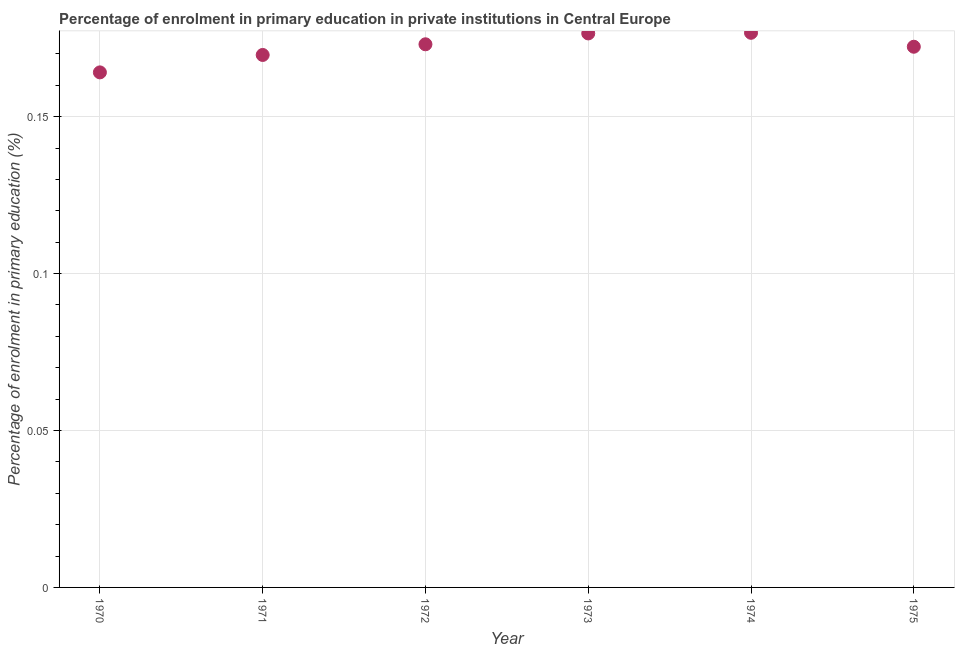What is the enrolment percentage in primary education in 1970?
Your answer should be very brief. 0.16. Across all years, what is the maximum enrolment percentage in primary education?
Make the answer very short. 0.18. Across all years, what is the minimum enrolment percentage in primary education?
Offer a very short reply. 0.16. In which year was the enrolment percentage in primary education maximum?
Provide a succinct answer. 1974. What is the sum of the enrolment percentage in primary education?
Provide a succinct answer. 1.03. What is the difference between the enrolment percentage in primary education in 1970 and 1974?
Provide a succinct answer. -0.01. What is the average enrolment percentage in primary education per year?
Make the answer very short. 0.17. What is the median enrolment percentage in primary education?
Offer a very short reply. 0.17. In how many years, is the enrolment percentage in primary education greater than 0.060000000000000005 %?
Ensure brevity in your answer.  6. Do a majority of the years between 1975 and 1971 (inclusive) have enrolment percentage in primary education greater than 0.060000000000000005 %?
Provide a succinct answer. Yes. What is the ratio of the enrolment percentage in primary education in 1972 to that in 1975?
Your answer should be compact. 1. Is the difference between the enrolment percentage in primary education in 1970 and 1973 greater than the difference between any two years?
Make the answer very short. No. What is the difference between the highest and the second highest enrolment percentage in primary education?
Give a very brief answer. 0. Is the sum of the enrolment percentage in primary education in 1970 and 1971 greater than the maximum enrolment percentage in primary education across all years?
Keep it short and to the point. Yes. What is the difference between the highest and the lowest enrolment percentage in primary education?
Give a very brief answer. 0.01. Does the enrolment percentage in primary education monotonically increase over the years?
Your answer should be very brief. No. How many dotlines are there?
Provide a succinct answer. 1. How many years are there in the graph?
Your response must be concise. 6. What is the difference between two consecutive major ticks on the Y-axis?
Ensure brevity in your answer.  0.05. Are the values on the major ticks of Y-axis written in scientific E-notation?
Provide a short and direct response. No. Does the graph contain any zero values?
Keep it short and to the point. No. Does the graph contain grids?
Offer a very short reply. Yes. What is the title of the graph?
Your answer should be very brief. Percentage of enrolment in primary education in private institutions in Central Europe. What is the label or title of the Y-axis?
Offer a very short reply. Percentage of enrolment in primary education (%). What is the Percentage of enrolment in primary education (%) in 1970?
Ensure brevity in your answer.  0.16. What is the Percentage of enrolment in primary education (%) in 1971?
Provide a succinct answer. 0.17. What is the Percentage of enrolment in primary education (%) in 1972?
Provide a succinct answer. 0.17. What is the Percentage of enrolment in primary education (%) in 1973?
Your answer should be compact. 0.18. What is the Percentage of enrolment in primary education (%) in 1974?
Your response must be concise. 0.18. What is the Percentage of enrolment in primary education (%) in 1975?
Your answer should be very brief. 0.17. What is the difference between the Percentage of enrolment in primary education (%) in 1970 and 1971?
Your answer should be compact. -0.01. What is the difference between the Percentage of enrolment in primary education (%) in 1970 and 1972?
Provide a succinct answer. -0.01. What is the difference between the Percentage of enrolment in primary education (%) in 1970 and 1973?
Make the answer very short. -0.01. What is the difference between the Percentage of enrolment in primary education (%) in 1970 and 1974?
Keep it short and to the point. -0.01. What is the difference between the Percentage of enrolment in primary education (%) in 1970 and 1975?
Provide a succinct answer. -0.01. What is the difference between the Percentage of enrolment in primary education (%) in 1971 and 1972?
Provide a succinct answer. -0. What is the difference between the Percentage of enrolment in primary education (%) in 1971 and 1973?
Offer a terse response. -0.01. What is the difference between the Percentage of enrolment in primary education (%) in 1971 and 1974?
Your response must be concise. -0.01. What is the difference between the Percentage of enrolment in primary education (%) in 1971 and 1975?
Keep it short and to the point. -0. What is the difference between the Percentage of enrolment in primary education (%) in 1972 and 1973?
Offer a very short reply. -0. What is the difference between the Percentage of enrolment in primary education (%) in 1972 and 1974?
Make the answer very short. -0. What is the difference between the Percentage of enrolment in primary education (%) in 1972 and 1975?
Ensure brevity in your answer.  0. What is the difference between the Percentage of enrolment in primary education (%) in 1973 and 1974?
Your response must be concise. -0. What is the difference between the Percentage of enrolment in primary education (%) in 1973 and 1975?
Offer a terse response. 0. What is the difference between the Percentage of enrolment in primary education (%) in 1974 and 1975?
Your answer should be compact. 0. What is the ratio of the Percentage of enrolment in primary education (%) in 1970 to that in 1972?
Make the answer very short. 0.95. What is the ratio of the Percentage of enrolment in primary education (%) in 1970 to that in 1974?
Provide a succinct answer. 0.93. What is the ratio of the Percentage of enrolment in primary education (%) in 1970 to that in 1975?
Make the answer very short. 0.95. What is the ratio of the Percentage of enrolment in primary education (%) in 1971 to that in 1973?
Make the answer very short. 0.96. What is the ratio of the Percentage of enrolment in primary education (%) in 1971 to that in 1975?
Your answer should be very brief. 0.98. What is the ratio of the Percentage of enrolment in primary education (%) in 1972 to that in 1973?
Your answer should be compact. 0.98. What is the ratio of the Percentage of enrolment in primary education (%) in 1972 to that in 1975?
Provide a succinct answer. 1. What is the ratio of the Percentage of enrolment in primary education (%) in 1973 to that in 1975?
Offer a very short reply. 1.02. What is the ratio of the Percentage of enrolment in primary education (%) in 1974 to that in 1975?
Your response must be concise. 1.03. 